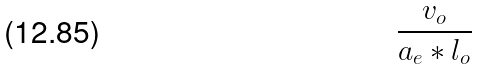Convert formula to latex. <formula><loc_0><loc_0><loc_500><loc_500>\frac { v _ { o } } { a _ { e } * l _ { o } }</formula> 